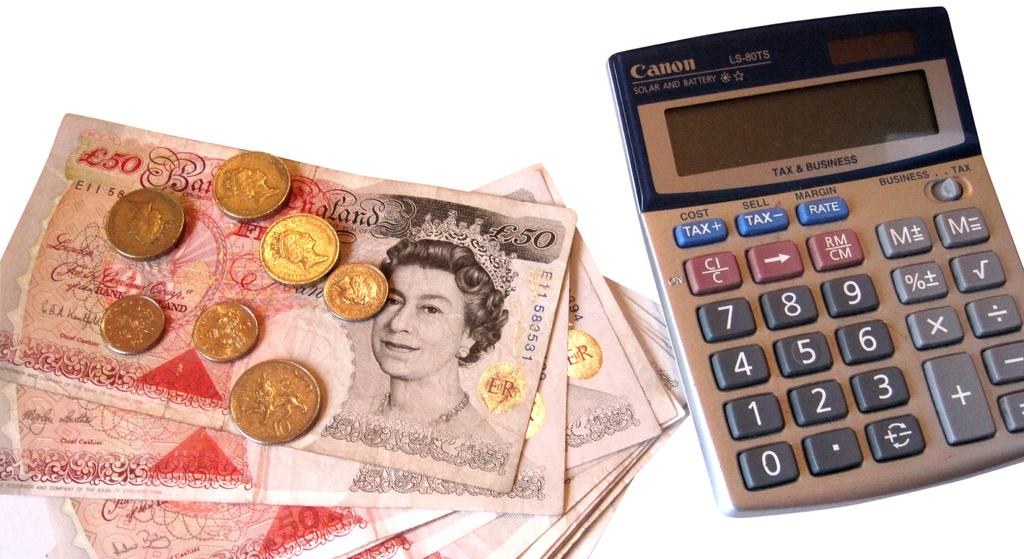<image>
Share a concise interpretation of the image provided. A canon calculator sits next to paper money and coins. 